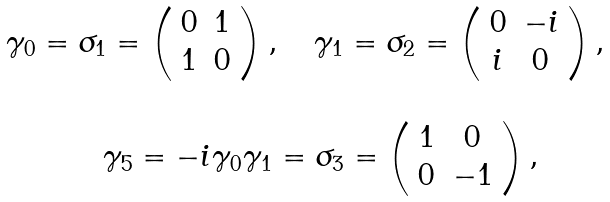<formula> <loc_0><loc_0><loc_500><loc_500>\begin{array} { c } \gamma _ { 0 } = \sigma _ { 1 } = \left ( \begin{array} { c c } 0 & 1 \\ 1 & 0 \end{array} \right ) , \quad \gamma _ { 1 } = \sigma _ { 2 } = \left ( \begin{array} { c c } 0 & - i \\ i & 0 \end{array} \right ) , \\ \\ \quad \gamma _ { 5 } = - i \gamma _ { 0 } \gamma _ { 1 } = \sigma _ { 3 } = \left ( \begin{array} { c c } 1 & 0 \\ 0 & - 1 \end{array} \right ) , \end{array}</formula> 